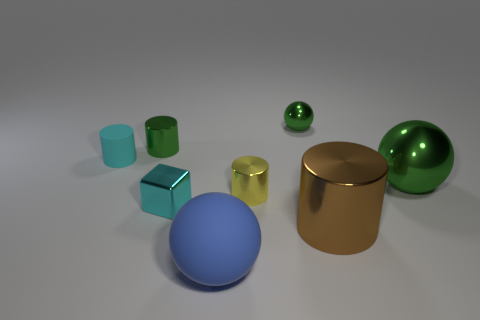Do the metal block and the tiny matte object have the same color?
Your answer should be compact. Yes. How many other things are the same shape as the small yellow thing?
Provide a succinct answer. 3. Is the size of the cyan object left of the cyan block the same as the cyan metal thing?
Provide a short and direct response. Yes. Is the number of metal spheres that are behind the large green ball greater than the number of tiny red shiny objects?
Provide a short and direct response. Yes. What number of small green metallic objects are in front of the green shiny sphere that is left of the big brown thing?
Offer a terse response. 1. Are there fewer small cyan rubber objects that are on the left side of the large cylinder than tiny cyan things?
Your response must be concise. Yes. There is a green thing to the left of the rubber sphere in front of the tiny cyan cylinder; is there a green cylinder left of it?
Ensure brevity in your answer.  No. Is the material of the cube the same as the big sphere to the right of the blue ball?
Provide a succinct answer. Yes. There is a matte object that is on the left side of the tiny cyan thing that is to the right of the tiny cyan cylinder; what is its color?
Your answer should be compact. Cyan. Are there any tiny shiny cylinders that have the same color as the metal cube?
Keep it short and to the point. No. 